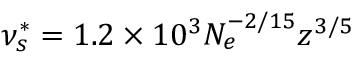Convert formula to latex. <formula><loc_0><loc_0><loc_500><loc_500>\nu _ { s } ^ { * } = 1 . 2 \times 1 0 ^ { 3 } N _ { e } ^ { - 2 / 1 5 } z ^ { 3 / 5 }</formula> 